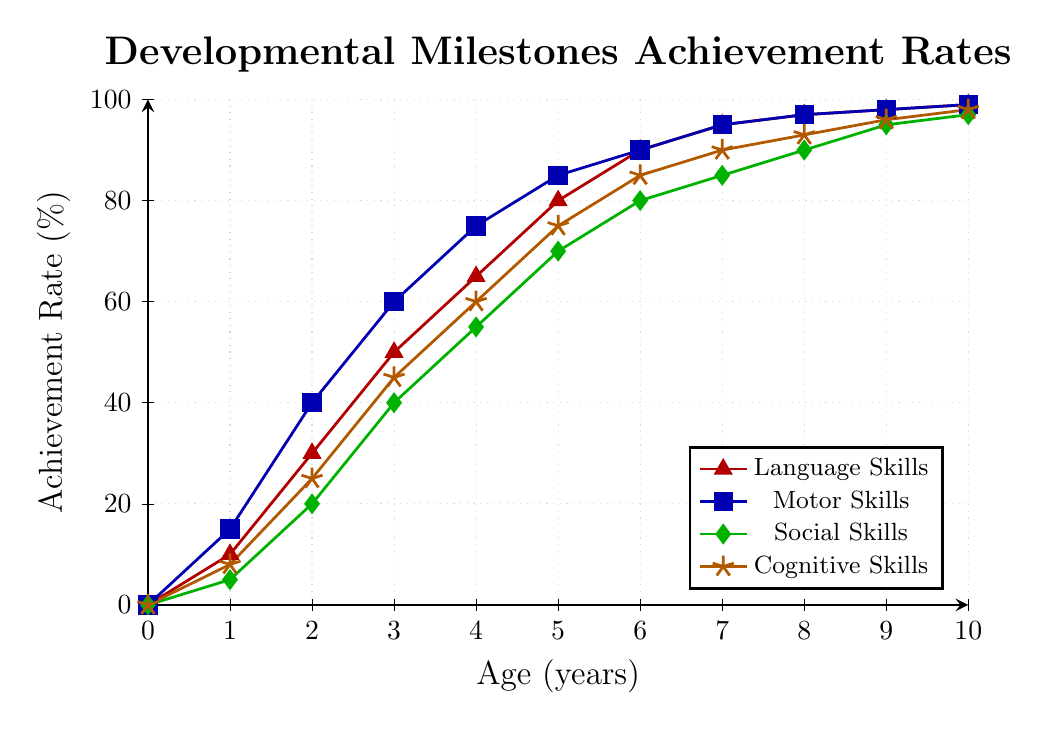How many percentage points have Social Skills improved between ages 3 and 7? Look at the Social Skills line (green) and note the percentages at ages 3 and 7, which are 40% and 85% respectively. Subtract the two values: 85% - 40% = 45 percentage points
Answer: 45 At what age do Motor Skills achieve at least 85%? Look at the Motor Skills line (blue) and find where the percentage meets or exceeds 85%. This happens at age 5.
Answer: 5 years Compare the achievement rates of Cognitive Skills and Language Skills at age 4. Which is higher and by how much? Locate the values for Cognitive Skills (60%) and Language Skills (65%) at age 4. Subtract the smaller value from the larger one: 65% - 60% = 5 percentage points. Language Skills are higher by 5 percentage points.
Answer: Language Skills, 5 percentage points What is the average achievement rate for Language Skills from age 1 to age 3? Identify the Language Skills percentages at ages 1, 2, and 3: 10%, 30%, and 50%. Sum them and divide by the number of points: (10 + 30 + 50) / 3 = 30%.
Answer: 30% Which skill category shows the most rapid increase between ages 0 and 1? Examine the increase for each skill from age 0 to 1. Language Skills: 10%, Motor Skills: 15%, Social Skills: 5%, Cognitive Skills: 8%. Motor Skills increase the most (15%).
Answer: Motor Skills At what age do all skills surpass the 50% achievement rate? Identify the age where all skills are above 50%. Language Skills, Motor Skills, Social Skills, and Cognitive Skills all surpass 50% starting at age 4.
Answer: 4 years What's the range of the achievement rates for Cognitive Skills from age 5 to age 10? Find the percentages for Cognitive Skills at ages 5 and 10, which are 75% and 98%. Subtract the smallest value from the largest: 98% - 75% = 23 percentage points.
Answer: 23 Which skill reaches 90% achievement first, and at what age? Identify the age at which each skill reaches 90%. Language Skills: 6 years, Motor Skills: 6 years, Social Skills: 8 years, and Cognitive Skills: 6 years. Several skills reach this at age 6, but Language Skills and Motor Skills reach it first simultaneously.
Answer: Language Skills/Motor Skills, 6 years Is there any age between 0-10 where all skill achievement rates are the same? Look at each age and compare the achievement rates for all skills. There is no age where all skill achievement rates are equal.
Answer: No 